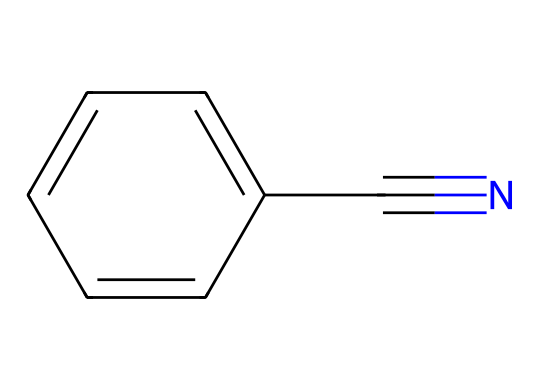What is the molecular formula of benzonitrile? The SMILES representation shows one benzene ring (C6H5), with a cyano group (C#N) attached. Thus, the total number of carbon atoms is 7 and nitrogen is 1, leading us to the molecular formula C7H5N.
Answer: C7H5N How many carbon atoms are present in benzonitrile? By analyzing the SMILES representation, we can see there are 6 carbon atoms from the benzene ring and 1 additional carbon from the cyano group, totaling 7 carbon atoms.
Answer: 7 How many double bonds are in the structure of benzonitrile? The benzene ring contains 3 double bonds (due to the alternating double bonds in aromatic compounds), and the cyano group has one triple bond between carbon and nitrogen, but no additional double bonds. So, only considering the double bonds, there are 3 in the benzene part of the structure.
Answer: 3 What type of functional group is present in benzonitrile? The presence of a cyano group (C#N) in the structure indicates that it is a nitrile, which is a functional group characterized by a carbon atom triple-bonded to a nitrogen atom.
Answer: nitrile What is the primary use of benzonitrile in industrial applications? Benzonitrile is widely used as a solvent in the production of various chemicals and for synthesizing pharmaceutical products, as well as being used in fragrance production.
Answer: solvent What effect does the cyano group have on the reactivity of benzonitrile? The cyano group is electron-withdrawing and increases the acidity of nearby hydrogen atoms while also influencing the reactivity in electrophilic aromatic substitutions, making benzonitrile more reactive compared to benzene itself.
Answer: increased reactivity 